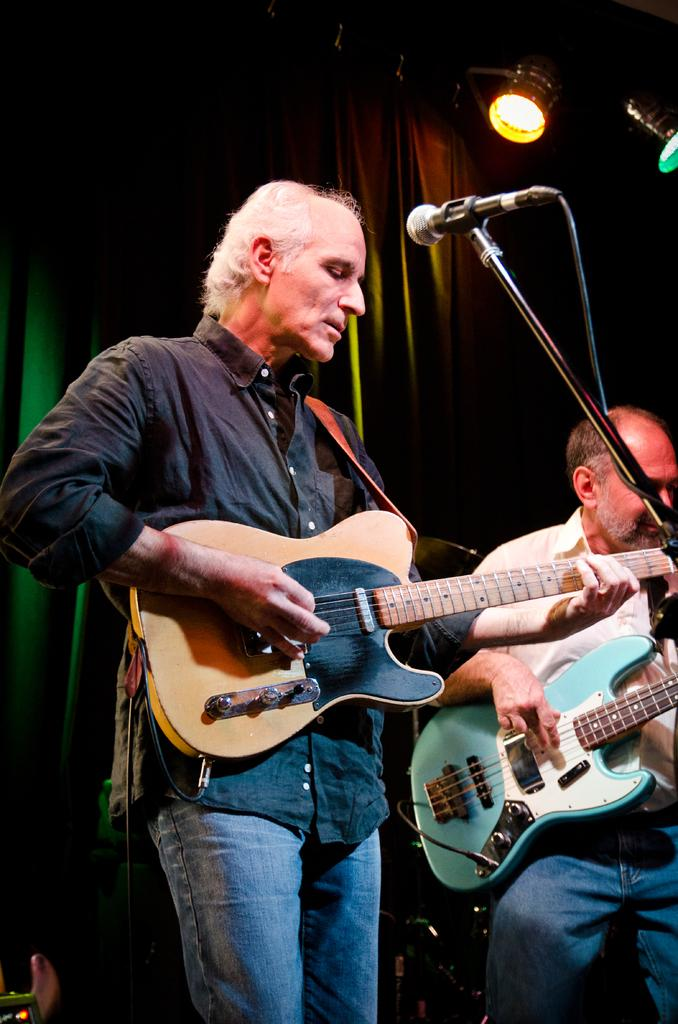How many people are in the image? There are two people in the image. What are the two people doing? The two people are playing guitar. What object is in front of the people? There is a microphone in front of the people. What can be seen in the background of the image? There is a curtain and lights visible in the background of the image. What type of cakes are being served to the people in the image? There are no cakes present in the image; the two people are playing guitar and there is a microphone in front of them. 